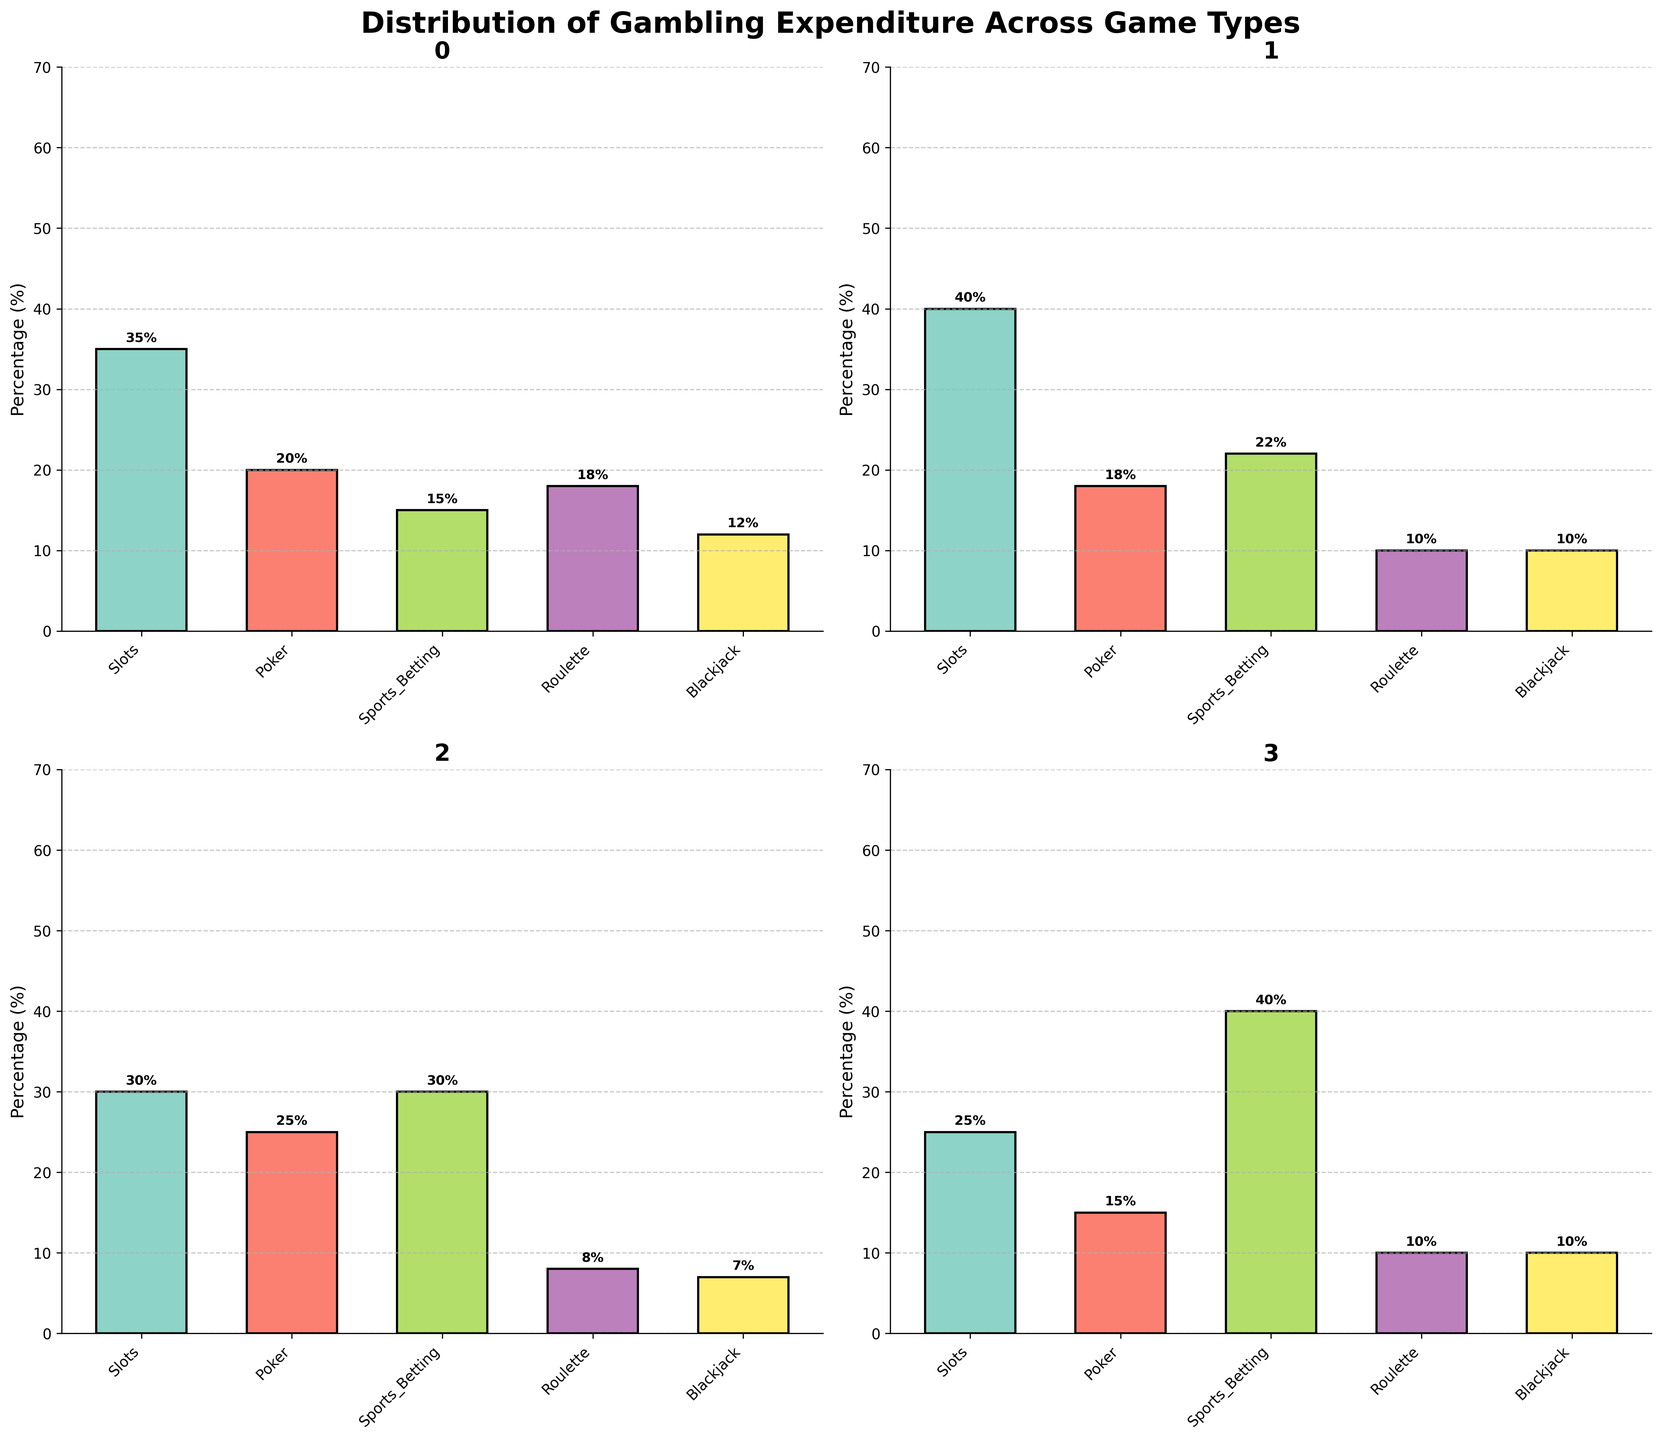What is the title of the figure? The title of the figure is typically located at the top and provides a summary of what the figure represents. In this case, the title is displayed above the subplots as 'Distribution of Gambling Expenditure Across Game Types'.
Answer: Distribution of Gambling Expenditure Across Game Types Which game type has the highest expenditure in Casino_A? To find the highest expenditure in Casino_A, look at the bar corresponding to Casino_A in the subplot. The tallest bar, or the highest percentage, within that subplot represents the game type with the highest expenditure. For Casino_A, the tallest bar represents 'Slots' with 35%.
Answer: Slots What is the average expenditure for Poker across all locations shown? To calculate the average, add up all the Poker expenditures and divide by the number of locations. The expenditures are: Casino_A (20), Casino_B (18), Online_Platform_X (25), Mobile_App_Y (15), Land_Based_Casino_Z (15), State_Lottery (5), Tribal_Casino (10). The total is 20+18+25+15+15+5+10 = 108. There are 7 locations, so the average is 108/7.
Answer: 15.4% Which location has the least expenditure on Blackjack? Compare the height of the Blackjack bars across all subplots. The bar with the smallest height indicates the least expenditure. The smallest values are shared across Online_Platform_X, State_Lottery, and Casino_B, each with an expenditure of 5%, 5%, and 10% respectively. The lowest value among these is 5%, found at Online_Platform_X and State_Lottery.
Answer: State_Lottery and Online_Platform_X Which location allocates the highest expenditure on Sports_Betting? Examine the Sports_Betting bars in each subplot and identify the tallest one. By comparing all Sports_Betting bars visually, the tallest bar corresponds to Mobile_App_Y with an expenditure of 40%.
Answer: Mobile_App_Y Which location has the most evenly distributed expenditure across all game types? Even distribution means the bar heights are fairly similar for all games. By visually assessing all subplots, Mobile_App_Y appears to show a more even bar distribution, although Poker has a slightly lower bar.
Answer: Online_Platform_X (although close with Casino_A) 